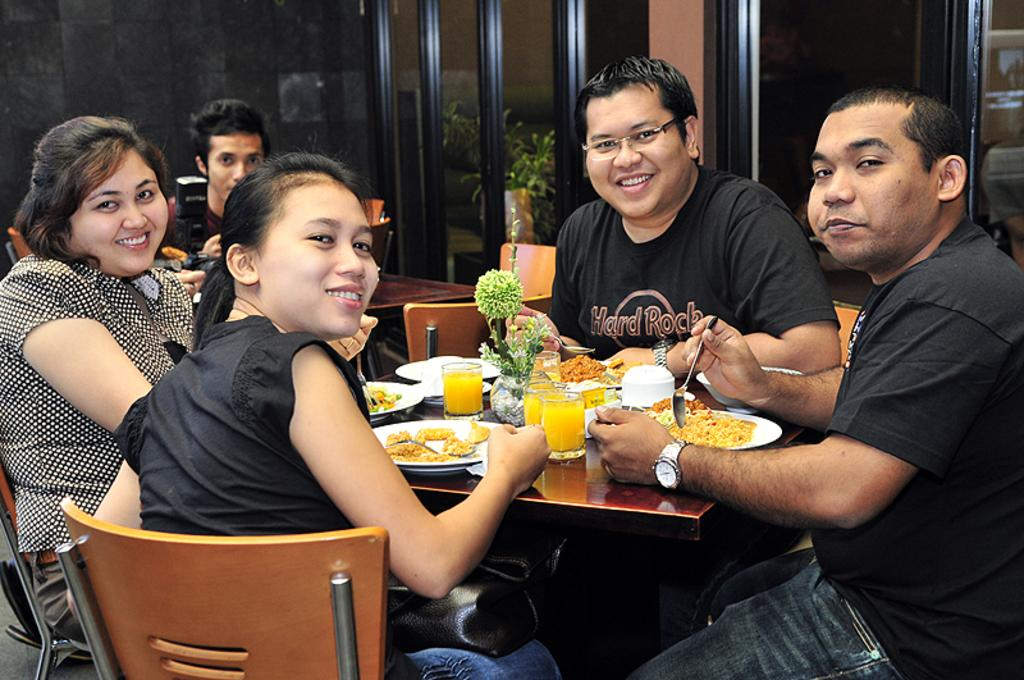What are the people in the room doing? The people in the room are sitting on chairs. What furniture is present in the room? There is a table in the room. What is on the table? Food is served on plates, and there are glasses of juice on the table. Are there any decorative items on the table? Yes, there is a flower vase on the table. How many frogs are sitting on the chairs with the people in the image? There are no frogs present in the image; only people are sitting on the chairs. 